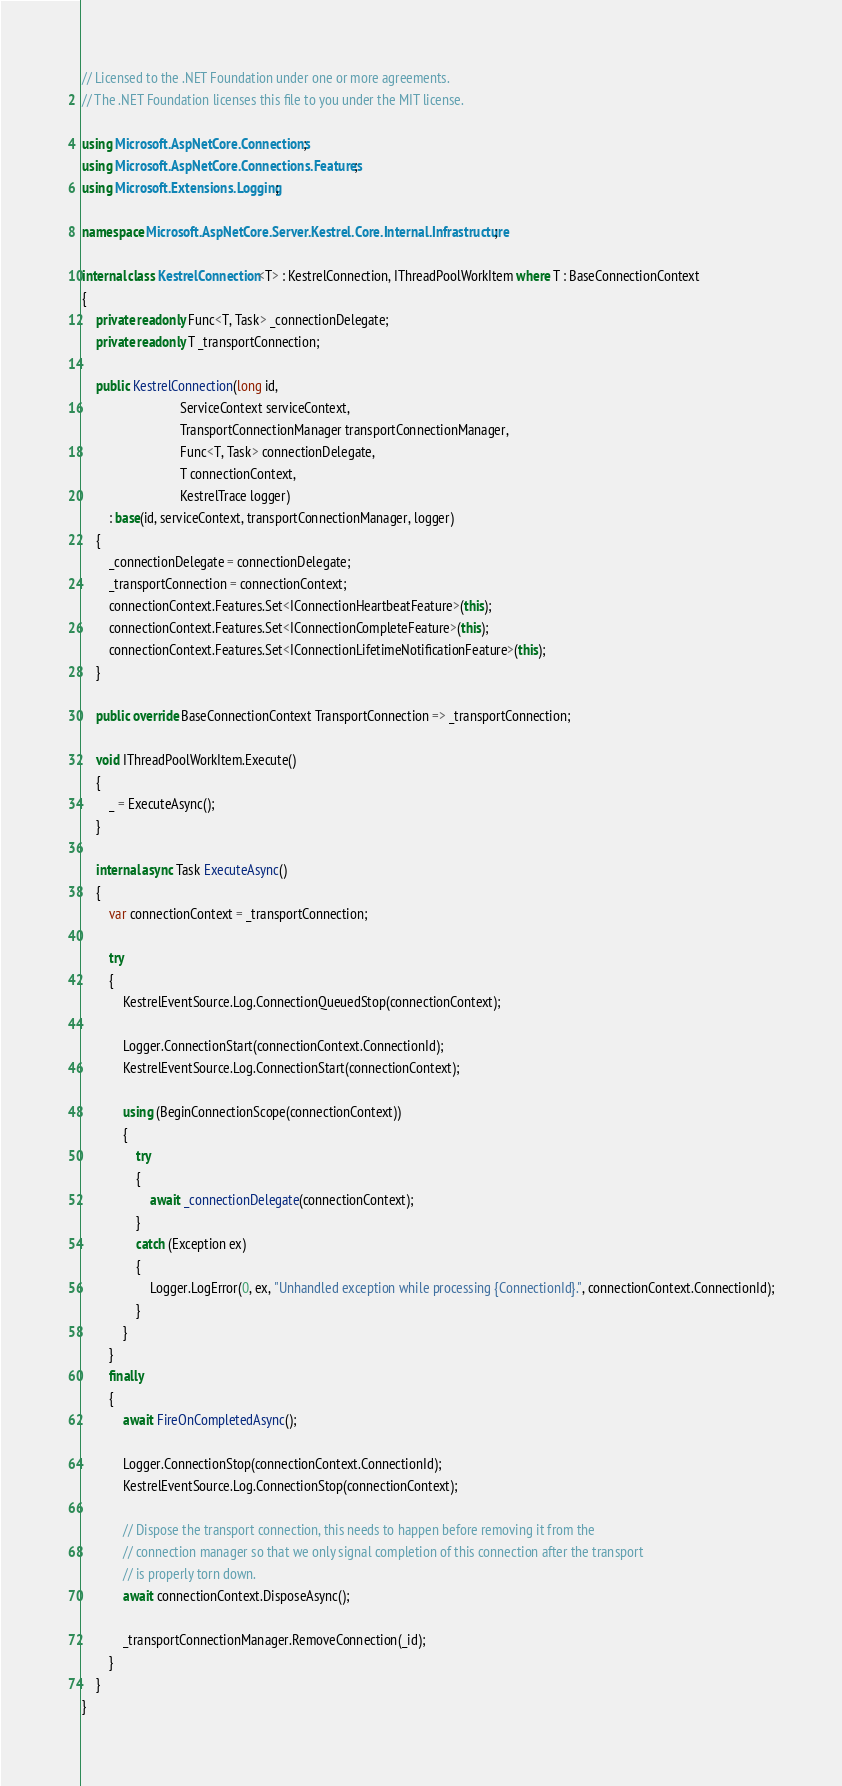<code> <loc_0><loc_0><loc_500><loc_500><_C#_>// Licensed to the .NET Foundation under one or more agreements.
// The .NET Foundation licenses this file to you under the MIT license.

using Microsoft.AspNetCore.Connections;
using Microsoft.AspNetCore.Connections.Features;
using Microsoft.Extensions.Logging;

namespace Microsoft.AspNetCore.Server.Kestrel.Core.Internal.Infrastructure;

internal class KestrelConnection<T> : KestrelConnection, IThreadPoolWorkItem where T : BaseConnectionContext
{
    private readonly Func<T, Task> _connectionDelegate;
    private readonly T _transportConnection;

    public KestrelConnection(long id,
                             ServiceContext serviceContext,
                             TransportConnectionManager transportConnectionManager,
                             Func<T, Task> connectionDelegate,
                             T connectionContext,
                             KestrelTrace logger)
        : base(id, serviceContext, transportConnectionManager, logger)
    {
        _connectionDelegate = connectionDelegate;
        _transportConnection = connectionContext;
        connectionContext.Features.Set<IConnectionHeartbeatFeature>(this);
        connectionContext.Features.Set<IConnectionCompleteFeature>(this);
        connectionContext.Features.Set<IConnectionLifetimeNotificationFeature>(this);
    }

    public override BaseConnectionContext TransportConnection => _transportConnection;

    void IThreadPoolWorkItem.Execute()
    {
        _ = ExecuteAsync();
    }

    internal async Task ExecuteAsync()
    {
        var connectionContext = _transportConnection;

        try
        {
            KestrelEventSource.Log.ConnectionQueuedStop(connectionContext);

            Logger.ConnectionStart(connectionContext.ConnectionId);
            KestrelEventSource.Log.ConnectionStart(connectionContext);

            using (BeginConnectionScope(connectionContext))
            {
                try
                {
                    await _connectionDelegate(connectionContext);
                }
                catch (Exception ex)
                {
                    Logger.LogError(0, ex, "Unhandled exception while processing {ConnectionId}.", connectionContext.ConnectionId);
                }
            }
        }
        finally
        {
            await FireOnCompletedAsync();

            Logger.ConnectionStop(connectionContext.ConnectionId);
            KestrelEventSource.Log.ConnectionStop(connectionContext);

            // Dispose the transport connection, this needs to happen before removing it from the
            // connection manager so that we only signal completion of this connection after the transport
            // is properly torn down.
            await connectionContext.DisposeAsync();

            _transportConnectionManager.RemoveConnection(_id);
        }
    }
}
</code> 